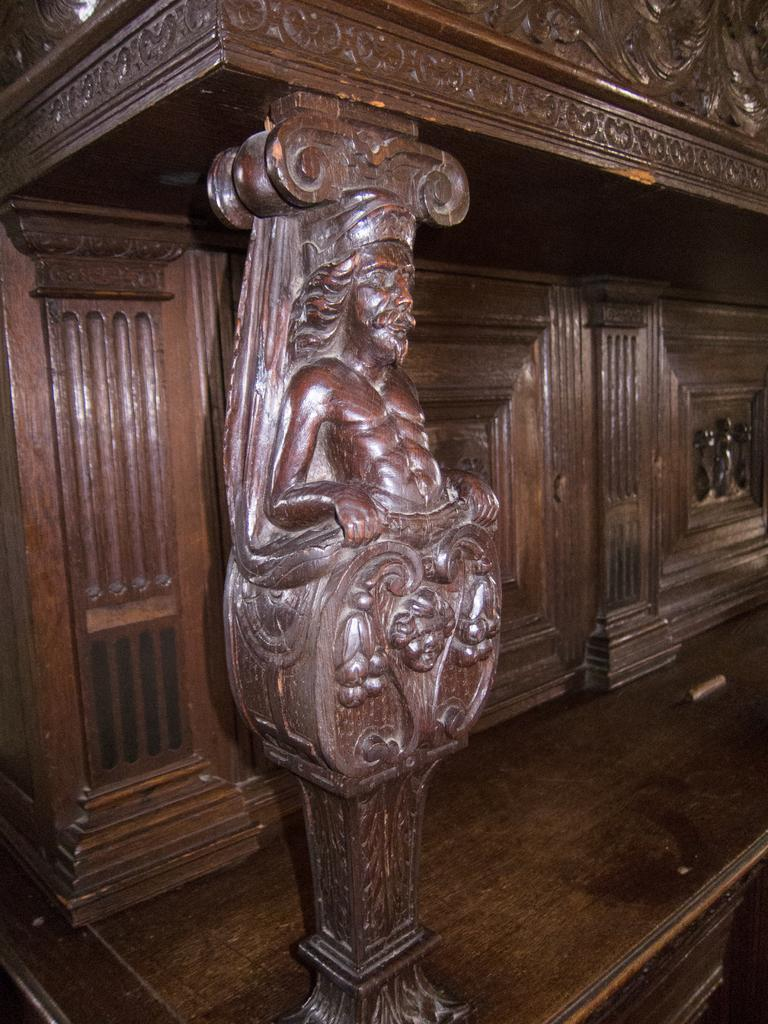What is on the wooden pole in the image? There are sculptures on a wooden pole in the image. What can be seen in the background of the image? There is a wooden wall in the background. How many pears are hanging from the wooden wall in the image? There are no pears present in the image; it features sculptures on a wooden pole and a wooden wall in the background. Is there any blood visible on the sculptures in the image? There is no blood visible in the image; it only features sculptures on a wooden pole and a wooden wall in the background. 